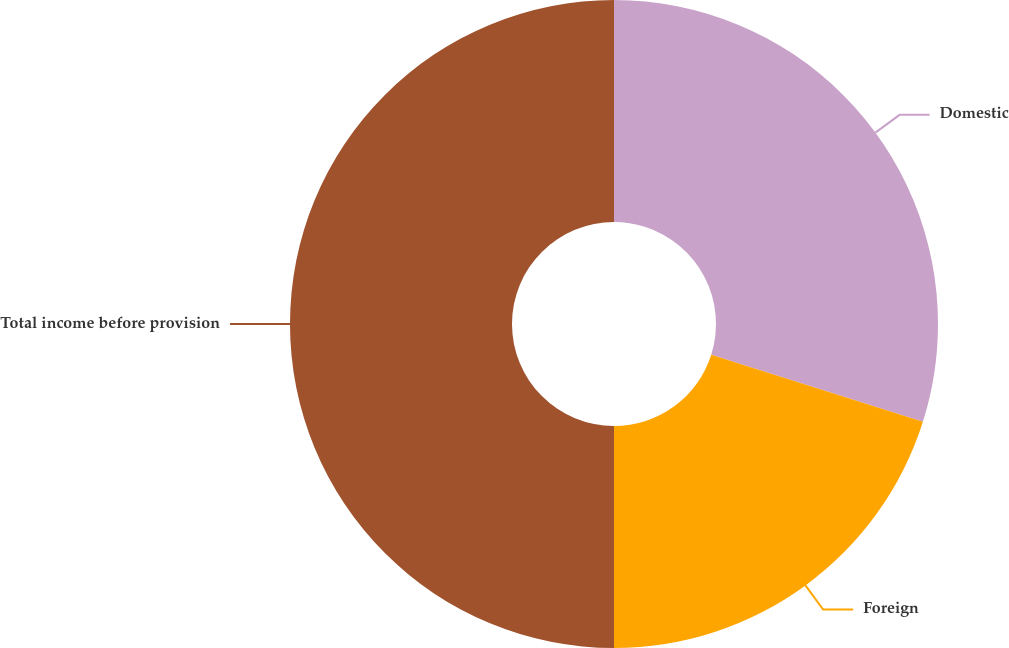<chart> <loc_0><loc_0><loc_500><loc_500><pie_chart><fcel>Domestic<fcel>Foreign<fcel>Total income before provision<nl><fcel>29.88%<fcel>20.12%<fcel>50.0%<nl></chart> 